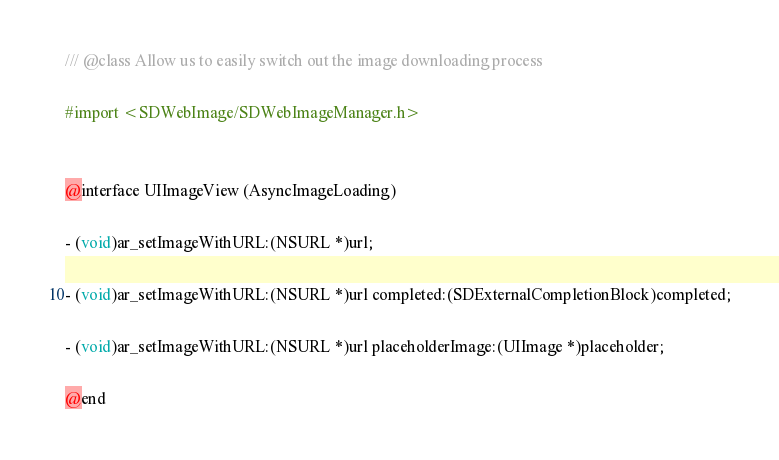Convert code to text. <code><loc_0><loc_0><loc_500><loc_500><_C_>/// @class Allow us to easily switch out the image downloading process

#import <SDWebImage/SDWebImageManager.h>


@interface UIImageView (AsyncImageLoading)

- (void)ar_setImageWithURL:(NSURL *)url;

- (void)ar_setImageWithURL:(NSURL *)url completed:(SDExternalCompletionBlock)completed;

- (void)ar_setImageWithURL:(NSURL *)url placeholderImage:(UIImage *)placeholder;

@end
</code> 